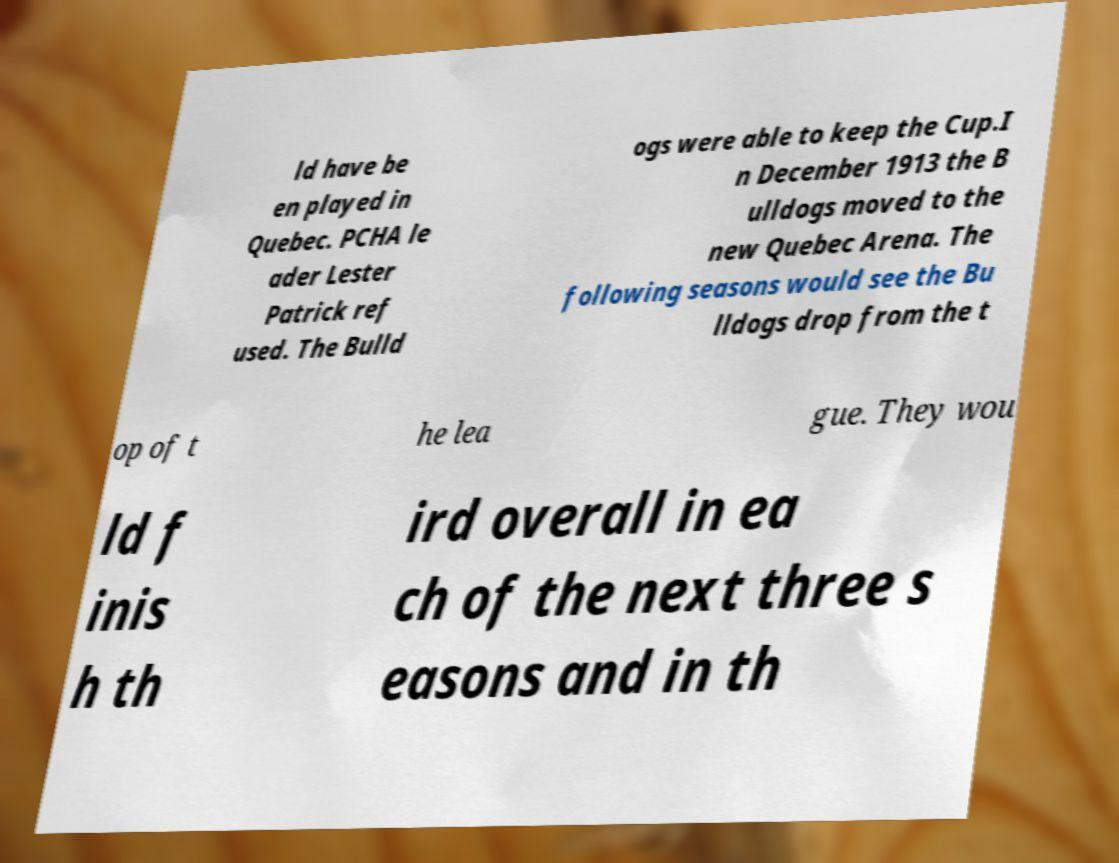Could you extract and type out the text from this image? ld have be en played in Quebec. PCHA le ader Lester Patrick ref used. The Bulld ogs were able to keep the Cup.I n December 1913 the B ulldogs moved to the new Quebec Arena. The following seasons would see the Bu lldogs drop from the t op of t he lea gue. They wou ld f inis h th ird overall in ea ch of the next three s easons and in th 